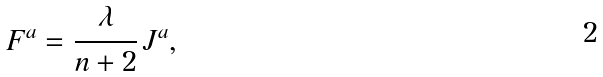Convert formula to latex. <formula><loc_0><loc_0><loc_500><loc_500>F ^ { a } = \cfrac { \lambda } { n + 2 } \, J ^ { a } ,</formula> 